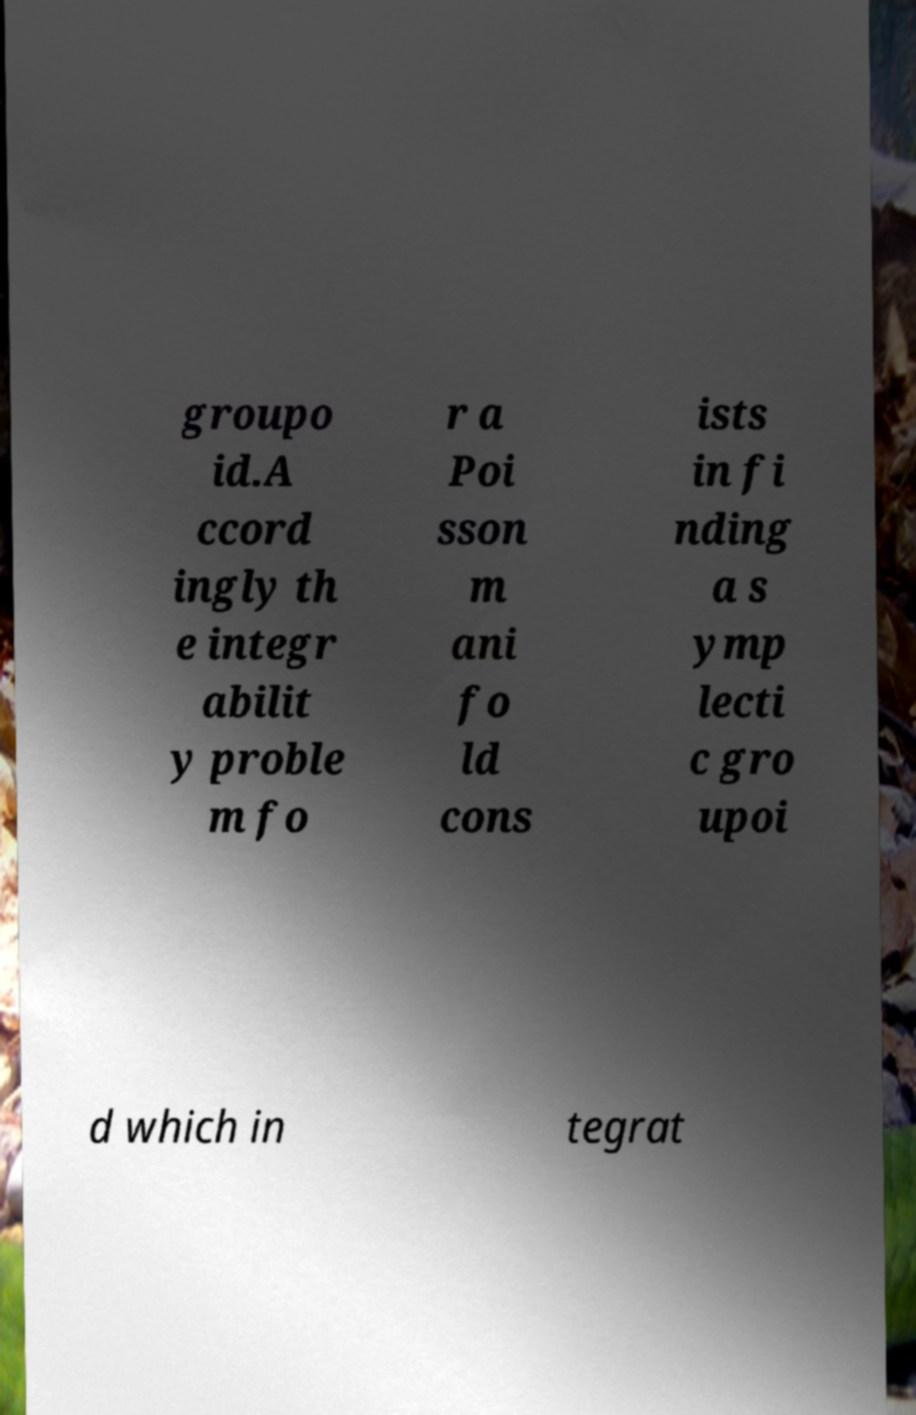What messages or text are displayed in this image? I need them in a readable, typed format. groupo id.A ccord ingly th e integr abilit y proble m fo r a Poi sson m ani fo ld cons ists in fi nding a s ymp lecti c gro upoi d which in tegrat 